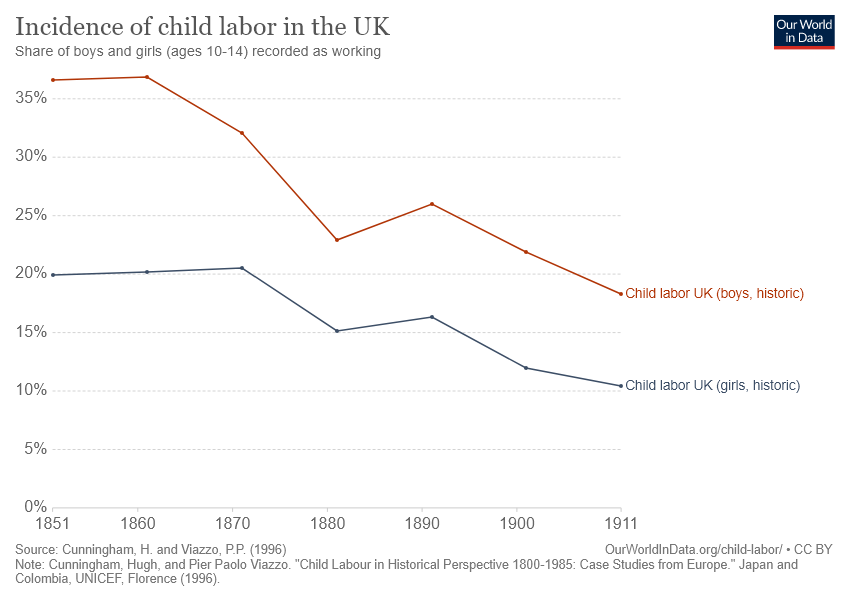Give some essential details in this illustration. The gender of children in the UK that saw more child labor over the given years was boys, based on historic data. In the year 1911, there were the fewest number of child laborers in the United Kingdom, specifically among boys, in recorded history. 